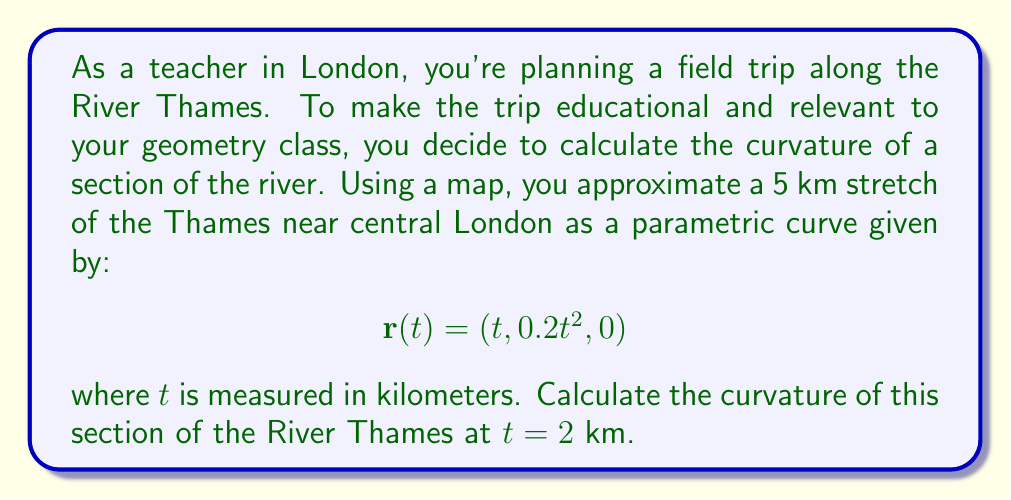Provide a solution to this math problem. To calculate the curvature of the parametric curve representing the River Thames, we'll follow these steps:

1) The curvature $\kappa$ of a parametric curve $r(t)$ is given by:

   $$\kappa = \frac{|\dot{r} \times \ddot{r}|}{|\dot{r}|^3}$$

2) First, let's calculate $\dot{r}(t)$ and $\ddot{r}(t)$:
   
   $$\dot{r}(t) = (1, 0.4t, 0)$$
   $$\ddot{r}(t) = (0, 0.4, 0)$$

3) Now, we need to calculate $\dot{r} \times \ddot{r}$:
   
   $$\dot{r} \times \ddot{r} = \begin{vmatrix}
   i & j & k \\
   1 & 0.4t & 0 \\
   0 & 0.4 & 0
   \end{vmatrix} = (0, 0, 0.4)$$

4) The magnitude of this cross product is:
   
   $$|\dot{r} \times \ddot{r}| = 0.4$$

5) Next, we calculate $|\dot{r}|$:
   
   $$|\dot{r}| = \sqrt{1^2 + (0.4t)^2 + 0^2} = \sqrt{1 + 0.16t^2}$$

6) Now we can substitute these values into our curvature formula:

   $$\kappa = \frac{0.4}{(1 + 0.16t^2)^{3/2}}$$

7) At $t = 2$ km, the curvature is:

   $$\kappa = \frac{0.4}{(1 + 0.16(2)^2)^{3/2}} = \frac{0.4}{(1.64)^{3/2}} \approx 0.1922$$

Therefore, the curvature of the River Thames at $t = 2$ km is approximately 0.1922 km^(-1).
Answer: $0.1922$ km^(-1) 